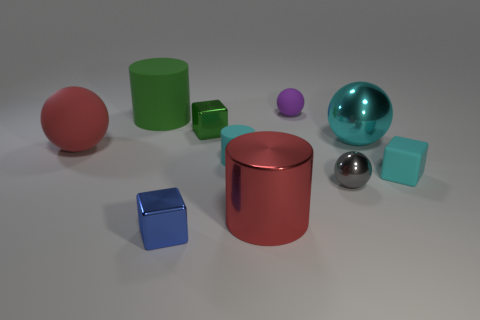Are there any reflective surfaces visible among the objects? Yes, several objects have reflective surfaces, including the large cyan sphere, the small silver sphere, and the red cylinder, all of which are reflecting light and their surroundings. 